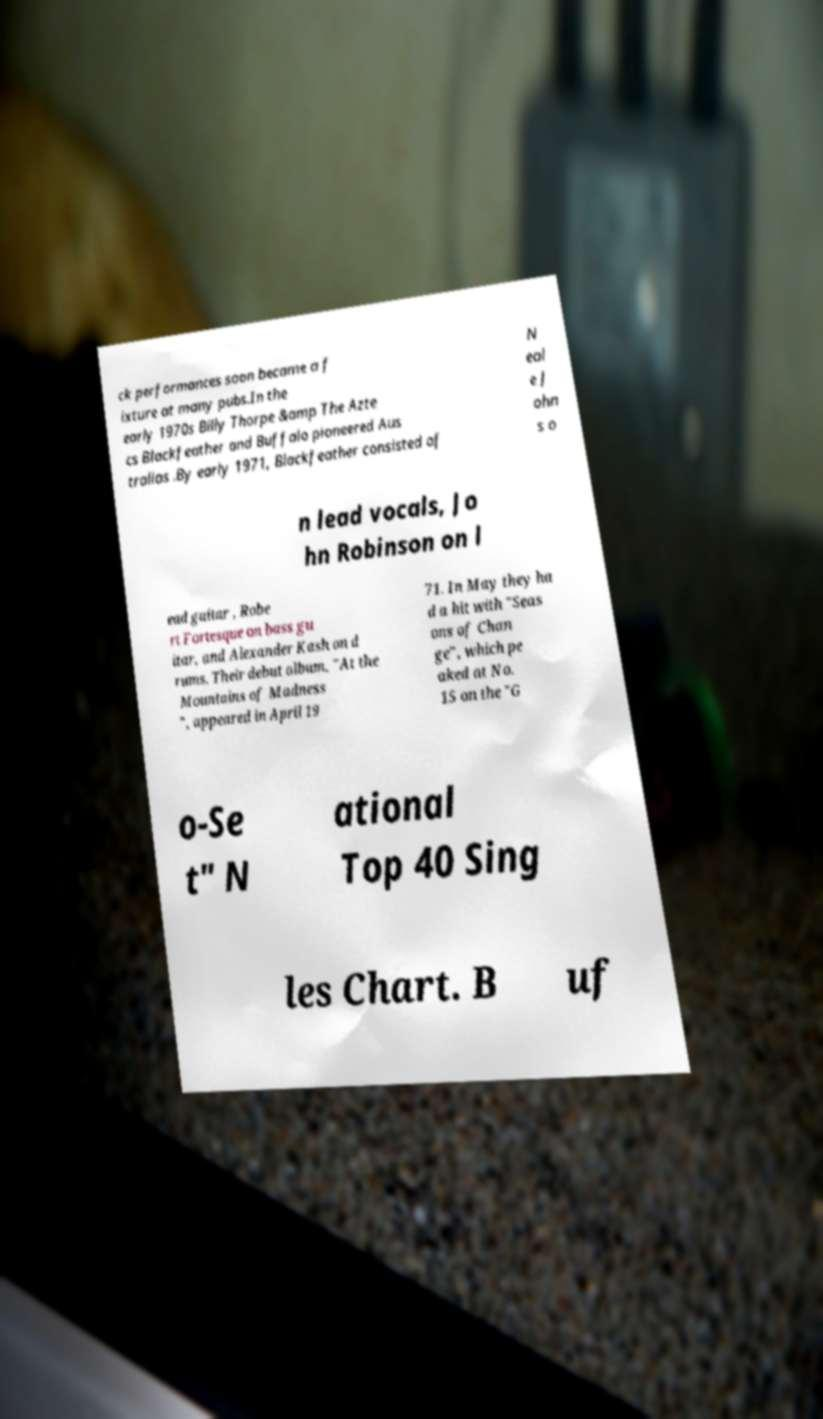Can you accurately transcribe the text from the provided image for me? ck performances soon became a f ixture at many pubs.In the early 1970s Billy Thorpe &amp The Azte cs Blackfeather and Buffalo pioneered Aus tralias .By early 1971, Blackfeather consisted of N eal e J ohn s o n lead vocals, Jo hn Robinson on l ead guitar , Robe rt Fortesque on bass gu itar, and Alexander Kash on d rums. Their debut album, "At the Mountains of Madness ", appeared in April 19 71. In May they ha d a hit with "Seas ons of Chan ge", which pe aked at No. 15 on the "G o-Se t" N ational Top 40 Sing les Chart. B uf 